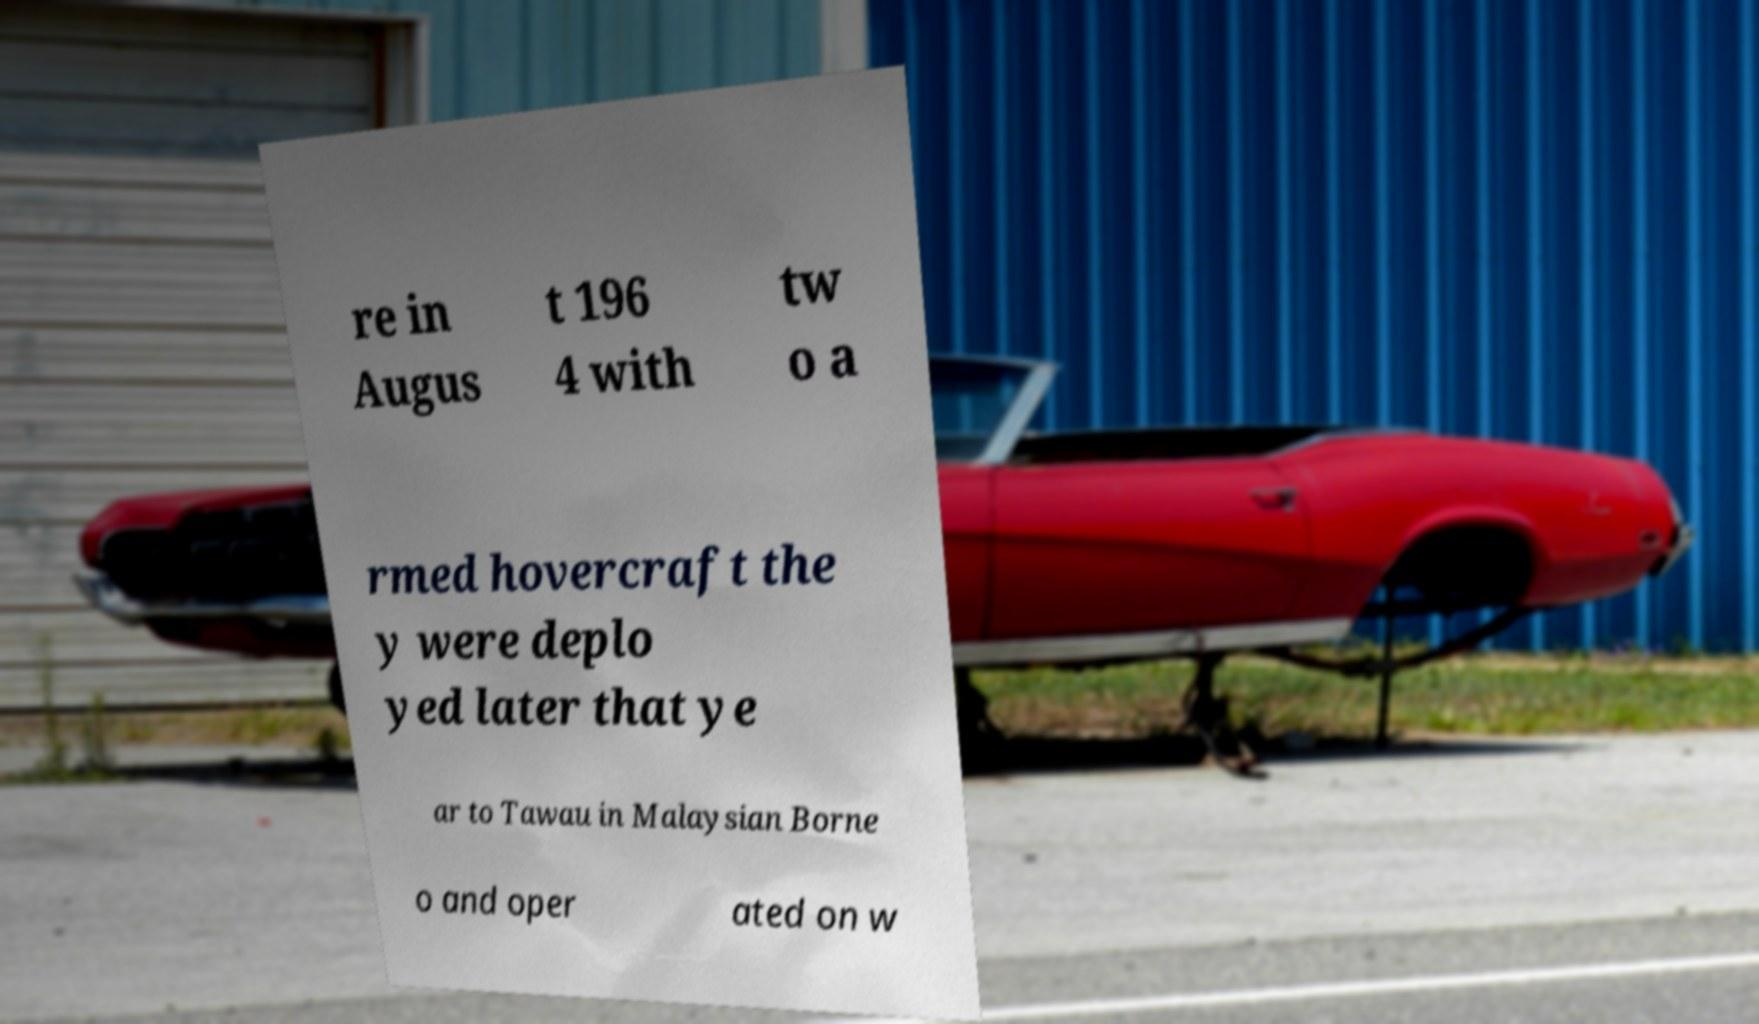Can you accurately transcribe the text from the provided image for me? re in Augus t 196 4 with tw o a rmed hovercraft the y were deplo yed later that ye ar to Tawau in Malaysian Borne o and oper ated on w 